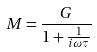<formula> <loc_0><loc_0><loc_500><loc_500>M = \frac { G } { 1 + \frac { 1 } { i \omega \tau } }</formula> 